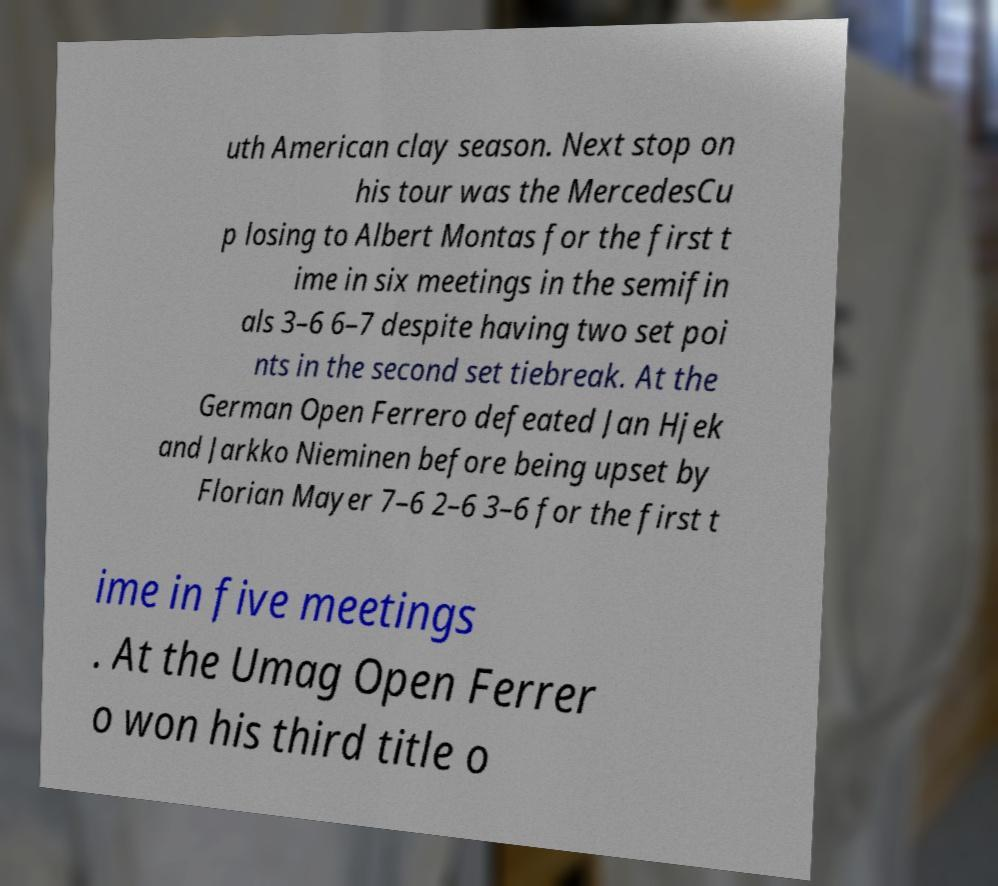Please identify and transcribe the text found in this image. uth American clay season. Next stop on his tour was the MercedesCu p losing to Albert Montas for the first t ime in six meetings in the semifin als 3–6 6–7 despite having two set poi nts in the second set tiebreak. At the German Open Ferrero defeated Jan Hjek and Jarkko Nieminen before being upset by Florian Mayer 7–6 2–6 3–6 for the first t ime in five meetings . At the Umag Open Ferrer o won his third title o 